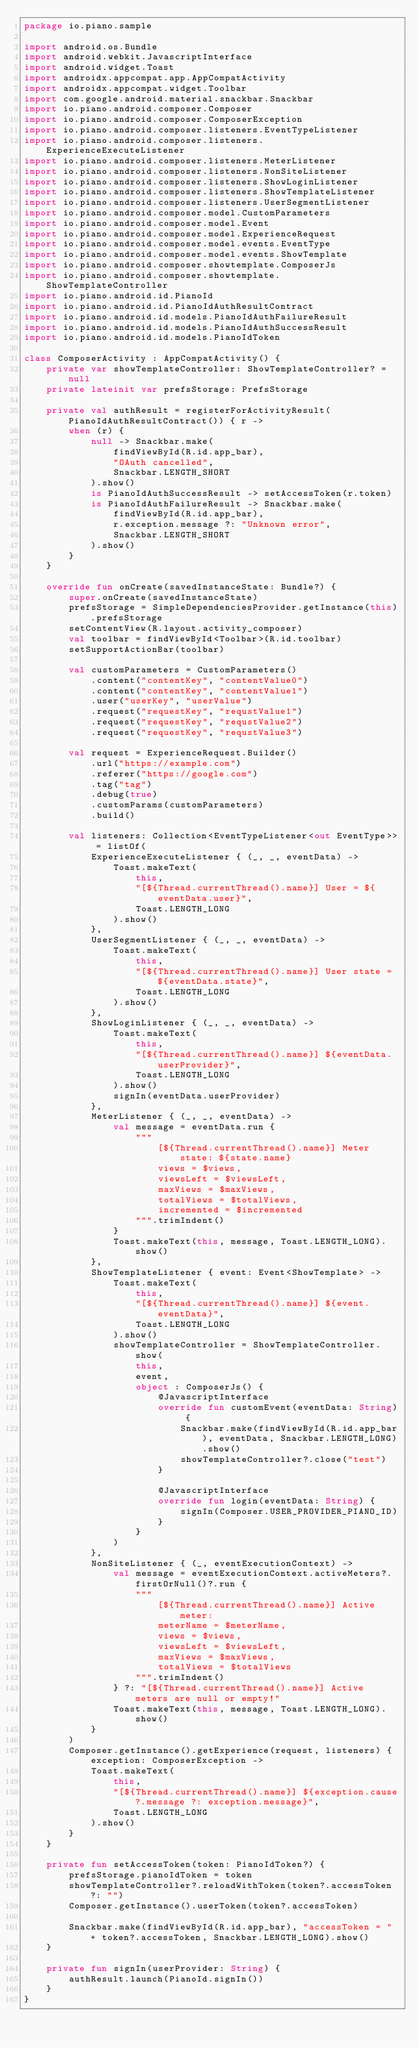Convert code to text. <code><loc_0><loc_0><loc_500><loc_500><_Kotlin_>package io.piano.sample

import android.os.Bundle
import android.webkit.JavascriptInterface
import android.widget.Toast
import androidx.appcompat.app.AppCompatActivity
import androidx.appcompat.widget.Toolbar
import com.google.android.material.snackbar.Snackbar
import io.piano.android.composer.Composer
import io.piano.android.composer.ComposerException
import io.piano.android.composer.listeners.EventTypeListener
import io.piano.android.composer.listeners.ExperienceExecuteListener
import io.piano.android.composer.listeners.MeterListener
import io.piano.android.composer.listeners.NonSiteListener
import io.piano.android.composer.listeners.ShowLoginListener
import io.piano.android.composer.listeners.ShowTemplateListener
import io.piano.android.composer.listeners.UserSegmentListener
import io.piano.android.composer.model.CustomParameters
import io.piano.android.composer.model.Event
import io.piano.android.composer.model.ExperienceRequest
import io.piano.android.composer.model.events.EventType
import io.piano.android.composer.model.events.ShowTemplate
import io.piano.android.composer.showtemplate.ComposerJs
import io.piano.android.composer.showtemplate.ShowTemplateController
import io.piano.android.id.PianoId
import io.piano.android.id.PianoIdAuthResultContract
import io.piano.android.id.models.PianoIdAuthFailureResult
import io.piano.android.id.models.PianoIdAuthSuccessResult
import io.piano.android.id.models.PianoIdToken

class ComposerActivity : AppCompatActivity() {
    private var showTemplateController: ShowTemplateController? = null
    private lateinit var prefsStorage: PrefsStorage

    private val authResult = registerForActivityResult(PianoIdAuthResultContract()) { r ->
        when (r) {
            null -> Snackbar.make(
                findViewById(R.id.app_bar),
                "OAuth cancelled",
                Snackbar.LENGTH_SHORT
            ).show()
            is PianoIdAuthSuccessResult -> setAccessToken(r.token)
            is PianoIdAuthFailureResult -> Snackbar.make(
                findViewById(R.id.app_bar),
                r.exception.message ?: "Unknown error",
                Snackbar.LENGTH_SHORT
            ).show()
        }
    }

    override fun onCreate(savedInstanceState: Bundle?) {
        super.onCreate(savedInstanceState)
        prefsStorage = SimpleDependenciesProvider.getInstance(this).prefsStorage
        setContentView(R.layout.activity_composer)
        val toolbar = findViewById<Toolbar>(R.id.toolbar)
        setSupportActionBar(toolbar)

        val customParameters = CustomParameters()
            .content("contentKey", "contentValue0")
            .content("contentKey", "contentValue1")
            .user("userKey", "userValue")
            .request("requestKey", "requstValue1")
            .request("requestKey", "requstValue2")
            .request("requestKey", "requstValue3")

        val request = ExperienceRequest.Builder()
            .url("https://example.com")
            .referer("https://google.com")
            .tag("tag")
            .debug(true)
            .customParams(customParameters)
            .build()

        val listeners: Collection<EventTypeListener<out EventType>> = listOf(
            ExperienceExecuteListener { (_, _, eventData) ->
                Toast.makeText(
                    this,
                    "[${Thread.currentThread().name}] User = ${eventData.user}",
                    Toast.LENGTH_LONG
                ).show()
            },
            UserSegmentListener { (_, _, eventData) ->
                Toast.makeText(
                    this,
                    "[${Thread.currentThread().name}] User state = ${eventData.state}",
                    Toast.LENGTH_LONG
                ).show()
            },
            ShowLoginListener { (_, _, eventData) ->
                Toast.makeText(
                    this,
                    "[${Thread.currentThread().name}] ${eventData.userProvider}",
                    Toast.LENGTH_LONG
                ).show()
                signIn(eventData.userProvider)
            },
            MeterListener { (_, _, eventData) ->
                val message = eventData.run {
                    """
                        [${Thread.currentThread().name}] Meter state: ${state.name}
                        views = $views,
                        viewsLeft = $viewsLeft,
                        maxViews = $maxViews,
                        totalViews = $totalViews,
                        incremented = $incremented
                    """.trimIndent()
                }
                Toast.makeText(this, message, Toast.LENGTH_LONG).show()
            },
            ShowTemplateListener { event: Event<ShowTemplate> ->
                Toast.makeText(
                    this,
                    "[${Thread.currentThread().name}] ${event.eventData}",
                    Toast.LENGTH_LONG
                ).show()
                showTemplateController = ShowTemplateController.show(
                    this,
                    event,
                    object : ComposerJs() {
                        @JavascriptInterface
                        override fun customEvent(eventData: String) {
                            Snackbar.make(findViewById(R.id.app_bar), eventData, Snackbar.LENGTH_LONG).show()
                            showTemplateController?.close("test")
                        }

                        @JavascriptInterface
                        override fun login(eventData: String) {
                            signIn(Composer.USER_PROVIDER_PIANO_ID)
                        }
                    }
                )
            },
            NonSiteListener { (_, eventExecutionContext) ->
                val message = eventExecutionContext.activeMeters?.firstOrNull()?.run {
                    """
                        [${Thread.currentThread().name}] Active meter:
                        meterName = $meterName,
                        views = $views,
                        viewsLeft = $viewsLeft,
                        maxViews = $maxViews,
                        totalViews = $totalViews
                    """.trimIndent()
                } ?: "[${Thread.currentThread().name}] Active meters are null or empty!"
                Toast.makeText(this, message, Toast.LENGTH_LONG).show()
            }
        )
        Composer.getInstance().getExperience(request, listeners) { exception: ComposerException ->
            Toast.makeText(
                this,
                "[${Thread.currentThread().name}] ${exception.cause?.message ?: exception.message}",
                Toast.LENGTH_LONG
            ).show()
        }
    }

    private fun setAccessToken(token: PianoIdToken?) {
        prefsStorage.pianoIdToken = token
        showTemplateController?.reloadWithToken(token?.accessToken ?: "")
        Composer.getInstance().userToken(token?.accessToken)

        Snackbar.make(findViewById(R.id.app_bar), "accessToken = " + token?.accessToken, Snackbar.LENGTH_LONG).show()
    }

    private fun signIn(userProvider: String) {
        authResult.launch(PianoId.signIn())
    }
}
</code> 